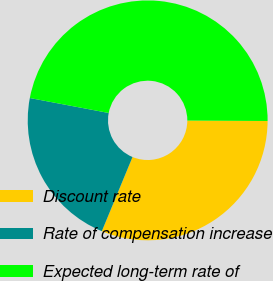<chart> <loc_0><loc_0><loc_500><loc_500><pie_chart><fcel>Discount rate<fcel>Rate of compensation increase<fcel>Expected long-term rate of<nl><fcel>31.16%<fcel>21.74%<fcel>47.1%<nl></chart> 